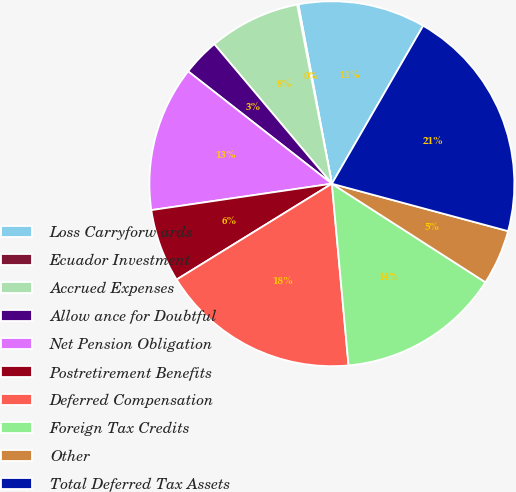Convert chart to OTSL. <chart><loc_0><loc_0><loc_500><loc_500><pie_chart><fcel>Loss Carryforw ards<fcel>Ecuador Investment<fcel>Accrued Expenses<fcel>Allow ance for Doubtful<fcel>Net Pension Obligation<fcel>Postretirement Benefits<fcel>Deferred Compensation<fcel>Foreign Tax Credits<fcel>Other<fcel>Total Deferred Tax Assets<nl><fcel>11.28%<fcel>0.11%<fcel>8.09%<fcel>3.3%<fcel>12.87%<fcel>6.49%<fcel>17.65%<fcel>14.46%<fcel>4.9%<fcel>20.84%<nl></chart> 